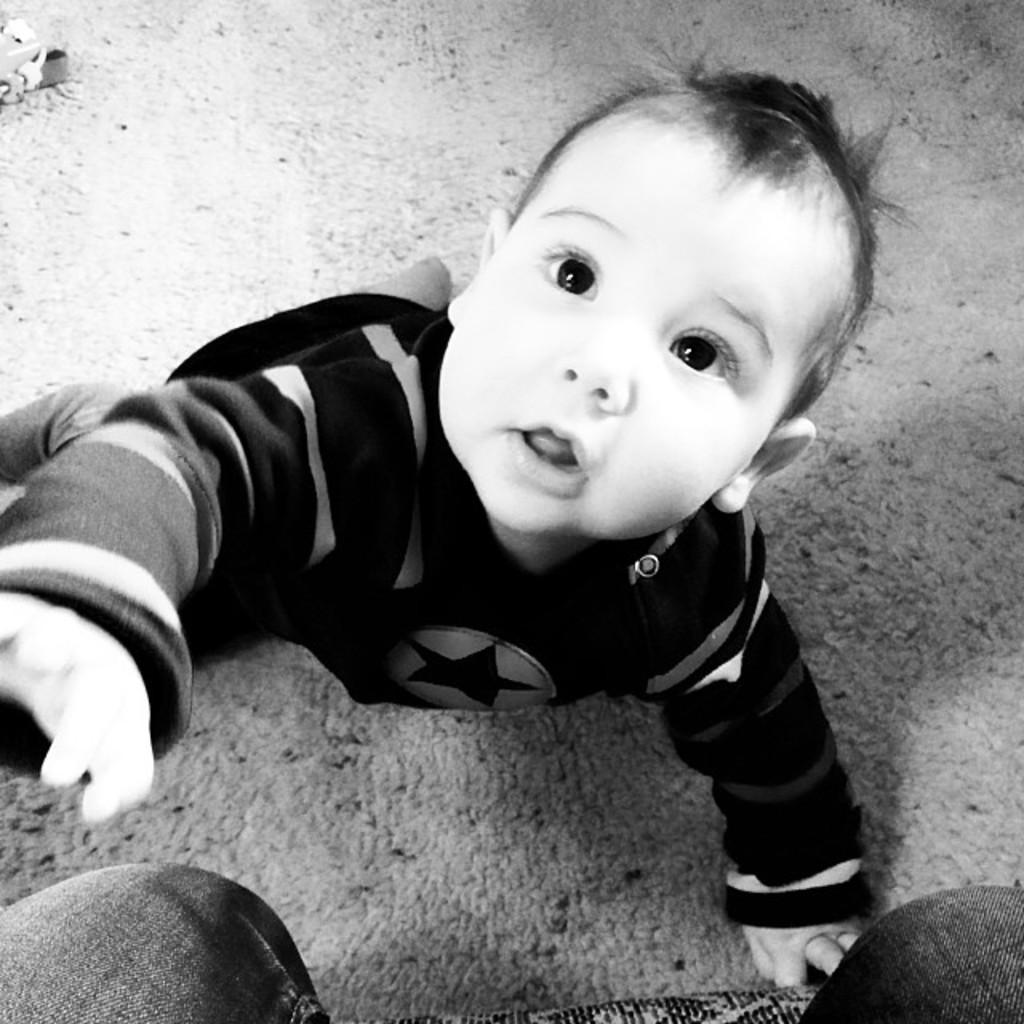What is the color scheme of the image? The image is black and white. What can be seen on the ground in the image? There is a baby on the ground in the image. What is the position of the person in the image? There is a person sitting on a chair in the image. How does the baby stretch in the image? There is no indication in the image that the baby is stretching, as the image is black and white and does not show any movement. 